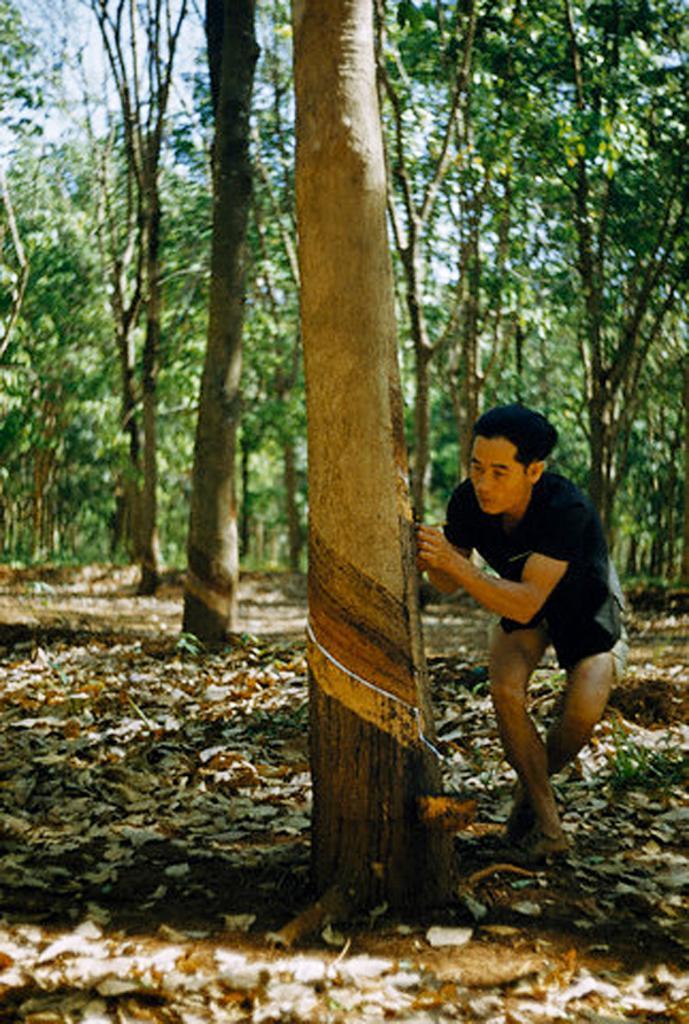Could you give a brief overview of what you see in this image? In this picture there is a man standing and holding the object. At the back there are trees. At the top there is sky. At the bottom there is ground and there are dried leaves. 